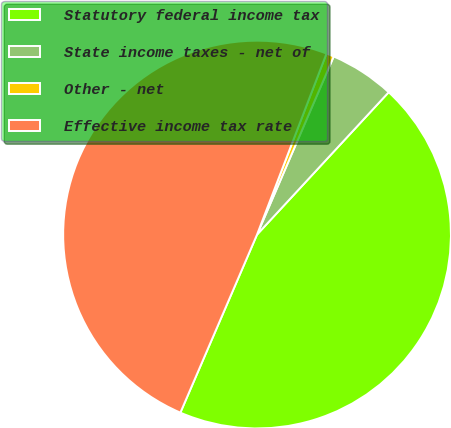Convert chart to OTSL. <chart><loc_0><loc_0><loc_500><loc_500><pie_chart><fcel>Statutory federal income tax<fcel>State income taxes - net of<fcel>Other - net<fcel>Effective income tax rate<nl><fcel>44.59%<fcel>5.41%<fcel>0.64%<fcel>49.36%<nl></chart> 